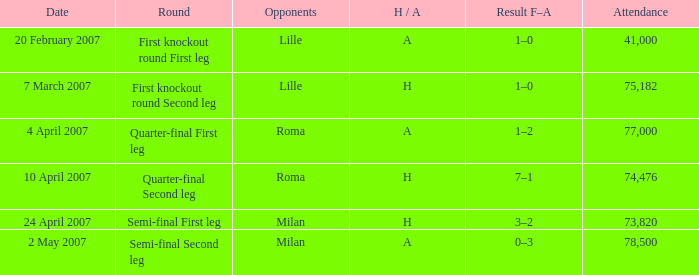How many people attended on 2 may 2007? 78500.0. 